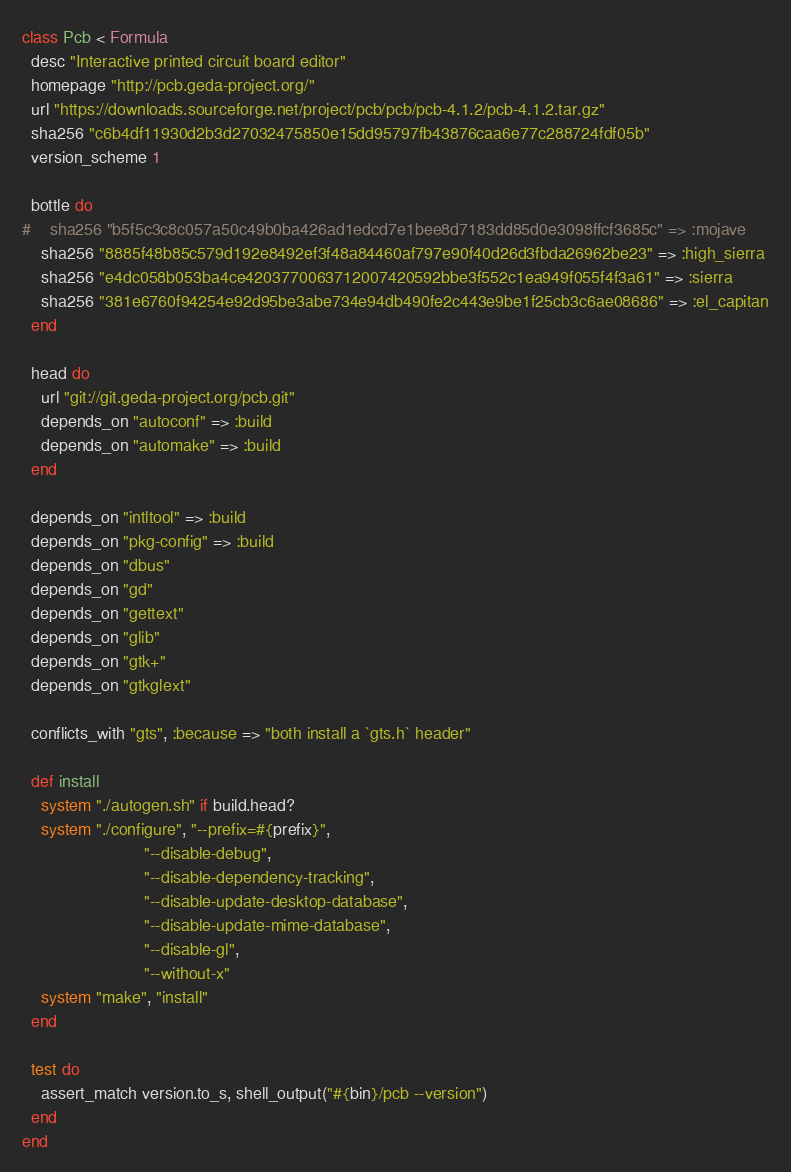Convert code to text. <code><loc_0><loc_0><loc_500><loc_500><_Ruby_>class Pcb < Formula
  desc "Interactive printed circuit board editor"
  homepage "http://pcb.geda-project.org/"
  url "https://downloads.sourceforge.net/project/pcb/pcb/pcb-4.1.2/pcb-4.1.2.tar.gz"
  sha256 "c6b4df11930d2b3d27032475850e15dd95797fb43876caa6e77c288724fdf05b"
  version_scheme 1

  bottle do
#    sha256 "b5f5c3c8c057a50c49b0ba426ad1edcd7e1bee8d7183dd85d0e3098ffcf3685c" => :mojave
    sha256 "8885f48b85c579d192e8492ef3f48a84460af797e90f40d26d3fbda26962be23" => :high_sierra
    sha256 "e4dc058b053ba4ce4203770063712007420592bbe3f552c1ea949f055f4f3a61" => :sierra
    sha256 "381e6760f94254e92d95be3abe734e94db490fe2c443e9be1f25cb3c6ae08686" => :el_capitan
  end

  head do
    url "git://git.geda-project.org/pcb.git"
    depends_on "autoconf" => :build
    depends_on "automake" => :build
  end

  depends_on "intltool" => :build
  depends_on "pkg-config" => :build
  depends_on "dbus"
  depends_on "gd"
  depends_on "gettext"
  depends_on "glib"
  depends_on "gtk+"
  depends_on "gtkglext"

  conflicts_with "gts", :because => "both install a `gts.h` header"

  def install
    system "./autogen.sh" if build.head?
    system "./configure", "--prefix=#{prefix}",
                          "--disable-debug",
                          "--disable-dependency-tracking",
                          "--disable-update-desktop-database",
                          "--disable-update-mime-database",
                          "--disable-gl",
                          "--without-x"
    system "make", "install"
  end

  test do
    assert_match version.to_s, shell_output("#{bin}/pcb --version")
  end
end
</code> 